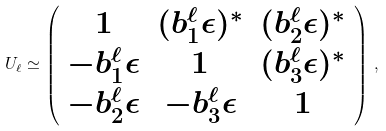Convert formula to latex. <formula><loc_0><loc_0><loc_500><loc_500>U _ { \ell } \simeq \left ( \begin{array} { c c c } 1 & ( b ^ { \ell } _ { 1 } \epsilon ) ^ { * } & ( b ^ { \ell } _ { 2 } \epsilon ) ^ { * } \\ - b ^ { \ell } _ { 1 } \epsilon & 1 & ( b ^ { \ell } _ { 3 } \epsilon ) ^ { * } \\ - b ^ { \ell } _ { 2 } \epsilon & - b ^ { \ell } _ { 3 } \epsilon & 1 \end{array} \right ) \, ,</formula> 